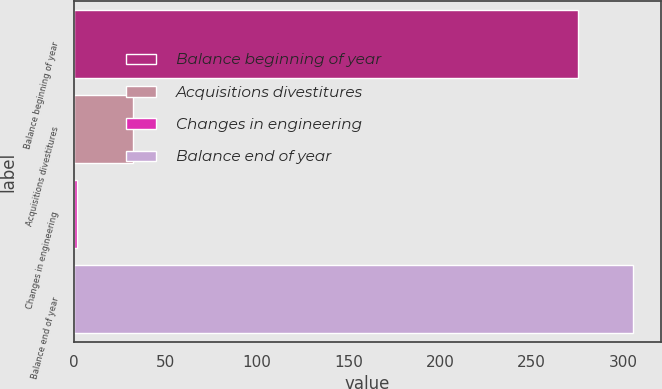Convert chart to OTSL. <chart><loc_0><loc_0><loc_500><loc_500><bar_chart><fcel>Balance beginning of year<fcel>Acquisitions divestitures<fcel>Changes in engineering<fcel>Balance end of year<nl><fcel>275<fcel>32.2<fcel>2<fcel>305.2<nl></chart> 